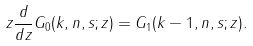Convert formula to latex. <formula><loc_0><loc_0><loc_500><loc_500>z \frac { d } { d z } G _ { 0 } ( k , n , s ; z ) = G _ { 1 } ( k - 1 , n , s ; z ) .</formula> 